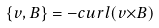<formula> <loc_0><loc_0><loc_500><loc_500>\{ v , B \} = - c u r l ( v { \times } B )</formula> 